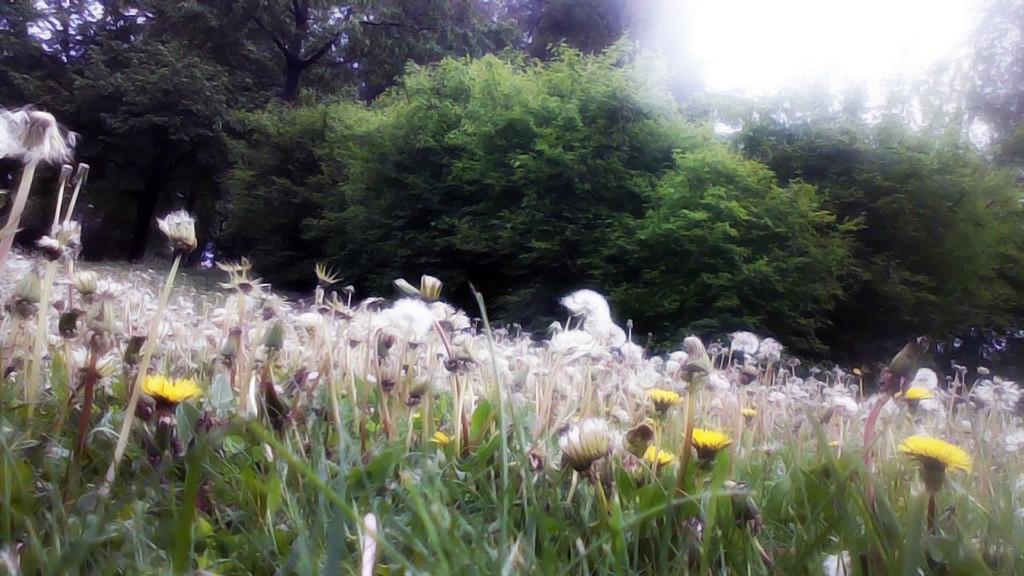Please provide a concise description of this image. In this picture I can observe white and yellow color flowers in the middle of the picture. In the background there are trees. 